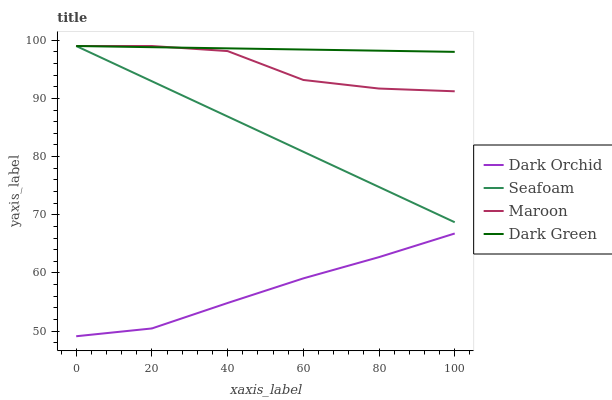Does Dark Orchid have the minimum area under the curve?
Answer yes or no. Yes. Does Dark Green have the maximum area under the curve?
Answer yes or no. Yes. Does Seafoam have the minimum area under the curve?
Answer yes or no. No. Does Seafoam have the maximum area under the curve?
Answer yes or no. No. Is Dark Green the smoothest?
Answer yes or no. Yes. Is Maroon the roughest?
Answer yes or no. Yes. Is Seafoam the smoothest?
Answer yes or no. No. Is Seafoam the roughest?
Answer yes or no. No. Does Seafoam have the lowest value?
Answer yes or no. No. Does Dark Green have the highest value?
Answer yes or no. Yes. Does Dark Orchid have the highest value?
Answer yes or no. No. Is Dark Orchid less than Dark Green?
Answer yes or no. Yes. Is Dark Green greater than Dark Orchid?
Answer yes or no. Yes. Does Maroon intersect Seafoam?
Answer yes or no. Yes. Is Maroon less than Seafoam?
Answer yes or no. No. Is Maroon greater than Seafoam?
Answer yes or no. No. Does Dark Orchid intersect Dark Green?
Answer yes or no. No. 